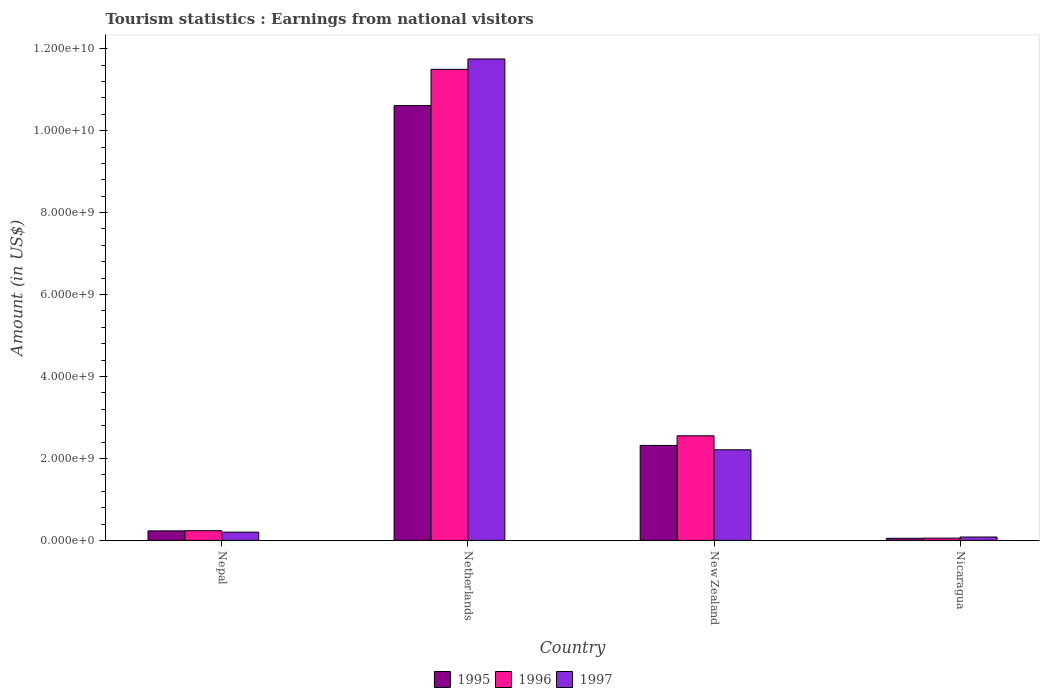How many different coloured bars are there?
Ensure brevity in your answer.  3. Are the number of bars per tick equal to the number of legend labels?
Your response must be concise. Yes. Are the number of bars on each tick of the X-axis equal?
Your response must be concise. Yes. How many bars are there on the 1st tick from the left?
Offer a very short reply. 3. What is the label of the 4th group of bars from the left?
Provide a short and direct response. Nicaragua. What is the earnings from national visitors in 1997 in Netherlands?
Give a very brief answer. 1.18e+1. Across all countries, what is the maximum earnings from national visitors in 1996?
Offer a terse response. 1.15e+1. Across all countries, what is the minimum earnings from national visitors in 1995?
Your response must be concise. 5.10e+07. In which country was the earnings from national visitors in 1995 maximum?
Ensure brevity in your answer.  Netherlands. In which country was the earnings from national visitors in 1996 minimum?
Ensure brevity in your answer.  Nicaragua. What is the total earnings from national visitors in 1996 in the graph?
Your response must be concise. 1.43e+1. What is the difference between the earnings from national visitors in 1996 in Nepal and that in Netherlands?
Provide a short and direct response. -1.13e+1. What is the difference between the earnings from national visitors in 1995 in Nepal and the earnings from national visitors in 1997 in Netherlands?
Your response must be concise. -1.15e+1. What is the average earnings from national visitors in 1996 per country?
Provide a succinct answer. 3.59e+09. What is the difference between the earnings from national visitors of/in 1995 and earnings from national visitors of/in 1997 in Netherlands?
Offer a terse response. -1.14e+09. What is the ratio of the earnings from national visitors in 1995 in Nepal to that in Netherlands?
Your answer should be compact. 0.02. Is the earnings from national visitors in 1996 in Nepal less than that in New Zealand?
Offer a very short reply. Yes. Is the difference between the earnings from national visitors in 1995 in Nepal and New Zealand greater than the difference between the earnings from national visitors in 1997 in Nepal and New Zealand?
Offer a terse response. No. What is the difference between the highest and the second highest earnings from national visitors in 1996?
Your answer should be very brief. 8.94e+09. What is the difference between the highest and the lowest earnings from national visitors in 1996?
Ensure brevity in your answer.  1.14e+1. In how many countries, is the earnings from national visitors in 1995 greater than the average earnings from national visitors in 1995 taken over all countries?
Your response must be concise. 1. Is the sum of the earnings from national visitors in 1997 in Netherlands and Nicaragua greater than the maximum earnings from national visitors in 1995 across all countries?
Your answer should be compact. Yes. What does the 1st bar from the left in New Zealand represents?
Offer a terse response. 1995. How many countries are there in the graph?
Offer a terse response. 4. What is the difference between two consecutive major ticks on the Y-axis?
Ensure brevity in your answer.  2.00e+09. Does the graph contain grids?
Make the answer very short. No. What is the title of the graph?
Provide a succinct answer. Tourism statistics : Earnings from national visitors. What is the Amount (in US$) in 1995 in Nepal?
Offer a very short reply. 2.32e+08. What is the Amount (in US$) in 1996 in Nepal?
Keep it short and to the point. 2.37e+08. What is the Amount (in US$) of 1997 in Nepal?
Your answer should be very brief. 2.01e+08. What is the Amount (in US$) of 1995 in Netherlands?
Offer a terse response. 1.06e+1. What is the Amount (in US$) of 1996 in Netherlands?
Provide a short and direct response. 1.15e+1. What is the Amount (in US$) in 1997 in Netherlands?
Keep it short and to the point. 1.18e+1. What is the Amount (in US$) of 1995 in New Zealand?
Provide a succinct answer. 2.32e+09. What is the Amount (in US$) in 1996 in New Zealand?
Offer a terse response. 2.55e+09. What is the Amount (in US$) in 1997 in New Zealand?
Provide a succinct answer. 2.21e+09. What is the Amount (in US$) in 1995 in Nicaragua?
Keep it short and to the point. 5.10e+07. What is the Amount (in US$) of 1996 in Nicaragua?
Make the answer very short. 5.50e+07. What is the Amount (in US$) of 1997 in Nicaragua?
Make the answer very short. 8.20e+07. Across all countries, what is the maximum Amount (in US$) in 1995?
Your answer should be compact. 1.06e+1. Across all countries, what is the maximum Amount (in US$) in 1996?
Your answer should be compact. 1.15e+1. Across all countries, what is the maximum Amount (in US$) of 1997?
Your answer should be very brief. 1.18e+1. Across all countries, what is the minimum Amount (in US$) of 1995?
Your response must be concise. 5.10e+07. Across all countries, what is the minimum Amount (in US$) in 1996?
Your answer should be very brief. 5.50e+07. Across all countries, what is the minimum Amount (in US$) in 1997?
Offer a very short reply. 8.20e+07. What is the total Amount (in US$) in 1995 in the graph?
Your answer should be compact. 1.32e+1. What is the total Amount (in US$) of 1996 in the graph?
Offer a very short reply. 1.43e+1. What is the total Amount (in US$) of 1997 in the graph?
Make the answer very short. 1.42e+1. What is the difference between the Amount (in US$) of 1995 in Nepal and that in Netherlands?
Give a very brief answer. -1.04e+1. What is the difference between the Amount (in US$) in 1996 in Nepal and that in Netherlands?
Your response must be concise. -1.13e+1. What is the difference between the Amount (in US$) in 1997 in Nepal and that in Netherlands?
Give a very brief answer. -1.15e+1. What is the difference between the Amount (in US$) in 1995 in Nepal and that in New Zealand?
Your answer should be very brief. -2.09e+09. What is the difference between the Amount (in US$) of 1996 in Nepal and that in New Zealand?
Your answer should be very brief. -2.32e+09. What is the difference between the Amount (in US$) of 1997 in Nepal and that in New Zealand?
Your answer should be very brief. -2.01e+09. What is the difference between the Amount (in US$) in 1995 in Nepal and that in Nicaragua?
Provide a succinct answer. 1.81e+08. What is the difference between the Amount (in US$) in 1996 in Nepal and that in Nicaragua?
Provide a succinct answer. 1.82e+08. What is the difference between the Amount (in US$) of 1997 in Nepal and that in Nicaragua?
Offer a terse response. 1.19e+08. What is the difference between the Amount (in US$) in 1995 in Netherlands and that in New Zealand?
Give a very brief answer. 8.29e+09. What is the difference between the Amount (in US$) of 1996 in Netherlands and that in New Zealand?
Offer a terse response. 8.94e+09. What is the difference between the Amount (in US$) in 1997 in Netherlands and that in New Zealand?
Your answer should be very brief. 9.54e+09. What is the difference between the Amount (in US$) in 1995 in Netherlands and that in Nicaragua?
Give a very brief answer. 1.06e+1. What is the difference between the Amount (in US$) in 1996 in Netherlands and that in Nicaragua?
Ensure brevity in your answer.  1.14e+1. What is the difference between the Amount (in US$) in 1997 in Netherlands and that in Nicaragua?
Ensure brevity in your answer.  1.17e+1. What is the difference between the Amount (in US$) of 1995 in New Zealand and that in Nicaragua?
Provide a succinct answer. 2.27e+09. What is the difference between the Amount (in US$) in 1996 in New Zealand and that in Nicaragua?
Ensure brevity in your answer.  2.50e+09. What is the difference between the Amount (in US$) in 1997 in New Zealand and that in Nicaragua?
Give a very brief answer. 2.13e+09. What is the difference between the Amount (in US$) in 1995 in Nepal and the Amount (in US$) in 1996 in Netherlands?
Keep it short and to the point. -1.13e+1. What is the difference between the Amount (in US$) in 1995 in Nepal and the Amount (in US$) in 1997 in Netherlands?
Make the answer very short. -1.15e+1. What is the difference between the Amount (in US$) in 1996 in Nepal and the Amount (in US$) in 1997 in Netherlands?
Ensure brevity in your answer.  -1.15e+1. What is the difference between the Amount (in US$) of 1995 in Nepal and the Amount (in US$) of 1996 in New Zealand?
Ensure brevity in your answer.  -2.32e+09. What is the difference between the Amount (in US$) of 1995 in Nepal and the Amount (in US$) of 1997 in New Zealand?
Offer a very short reply. -1.98e+09. What is the difference between the Amount (in US$) of 1996 in Nepal and the Amount (in US$) of 1997 in New Zealand?
Provide a succinct answer. -1.97e+09. What is the difference between the Amount (in US$) in 1995 in Nepal and the Amount (in US$) in 1996 in Nicaragua?
Provide a succinct answer. 1.77e+08. What is the difference between the Amount (in US$) of 1995 in Nepal and the Amount (in US$) of 1997 in Nicaragua?
Ensure brevity in your answer.  1.50e+08. What is the difference between the Amount (in US$) in 1996 in Nepal and the Amount (in US$) in 1997 in Nicaragua?
Offer a terse response. 1.55e+08. What is the difference between the Amount (in US$) of 1995 in Netherlands and the Amount (in US$) of 1996 in New Zealand?
Provide a succinct answer. 8.06e+09. What is the difference between the Amount (in US$) of 1995 in Netherlands and the Amount (in US$) of 1997 in New Zealand?
Your response must be concise. 8.40e+09. What is the difference between the Amount (in US$) of 1996 in Netherlands and the Amount (in US$) of 1997 in New Zealand?
Keep it short and to the point. 9.29e+09. What is the difference between the Amount (in US$) in 1995 in Netherlands and the Amount (in US$) in 1996 in Nicaragua?
Make the answer very short. 1.06e+1. What is the difference between the Amount (in US$) in 1995 in Netherlands and the Amount (in US$) in 1997 in Nicaragua?
Offer a terse response. 1.05e+1. What is the difference between the Amount (in US$) of 1996 in Netherlands and the Amount (in US$) of 1997 in Nicaragua?
Your response must be concise. 1.14e+1. What is the difference between the Amount (in US$) of 1995 in New Zealand and the Amount (in US$) of 1996 in Nicaragua?
Make the answer very short. 2.26e+09. What is the difference between the Amount (in US$) in 1995 in New Zealand and the Amount (in US$) in 1997 in Nicaragua?
Make the answer very short. 2.24e+09. What is the difference between the Amount (in US$) of 1996 in New Zealand and the Amount (in US$) of 1997 in Nicaragua?
Offer a terse response. 2.47e+09. What is the average Amount (in US$) of 1995 per country?
Provide a succinct answer. 3.30e+09. What is the average Amount (in US$) of 1996 per country?
Your answer should be very brief. 3.59e+09. What is the average Amount (in US$) in 1997 per country?
Offer a terse response. 3.56e+09. What is the difference between the Amount (in US$) in 1995 and Amount (in US$) in 1996 in Nepal?
Offer a terse response. -5.00e+06. What is the difference between the Amount (in US$) in 1995 and Amount (in US$) in 1997 in Nepal?
Give a very brief answer. 3.10e+07. What is the difference between the Amount (in US$) in 1996 and Amount (in US$) in 1997 in Nepal?
Your answer should be compact. 3.60e+07. What is the difference between the Amount (in US$) of 1995 and Amount (in US$) of 1996 in Netherlands?
Give a very brief answer. -8.86e+08. What is the difference between the Amount (in US$) in 1995 and Amount (in US$) in 1997 in Netherlands?
Provide a succinct answer. -1.14e+09. What is the difference between the Amount (in US$) of 1996 and Amount (in US$) of 1997 in Netherlands?
Offer a terse response. -2.53e+08. What is the difference between the Amount (in US$) in 1995 and Amount (in US$) in 1996 in New Zealand?
Make the answer very short. -2.35e+08. What is the difference between the Amount (in US$) of 1995 and Amount (in US$) of 1997 in New Zealand?
Your answer should be compact. 1.07e+08. What is the difference between the Amount (in US$) in 1996 and Amount (in US$) in 1997 in New Zealand?
Ensure brevity in your answer.  3.42e+08. What is the difference between the Amount (in US$) in 1995 and Amount (in US$) in 1997 in Nicaragua?
Provide a succinct answer. -3.10e+07. What is the difference between the Amount (in US$) of 1996 and Amount (in US$) of 1997 in Nicaragua?
Make the answer very short. -2.70e+07. What is the ratio of the Amount (in US$) in 1995 in Nepal to that in Netherlands?
Your answer should be compact. 0.02. What is the ratio of the Amount (in US$) of 1996 in Nepal to that in Netherlands?
Provide a short and direct response. 0.02. What is the ratio of the Amount (in US$) of 1997 in Nepal to that in Netherlands?
Give a very brief answer. 0.02. What is the ratio of the Amount (in US$) of 1995 in Nepal to that in New Zealand?
Ensure brevity in your answer.  0.1. What is the ratio of the Amount (in US$) of 1996 in Nepal to that in New Zealand?
Your response must be concise. 0.09. What is the ratio of the Amount (in US$) in 1997 in Nepal to that in New Zealand?
Your answer should be compact. 0.09. What is the ratio of the Amount (in US$) in 1995 in Nepal to that in Nicaragua?
Your answer should be very brief. 4.55. What is the ratio of the Amount (in US$) in 1996 in Nepal to that in Nicaragua?
Your answer should be compact. 4.31. What is the ratio of the Amount (in US$) in 1997 in Nepal to that in Nicaragua?
Your answer should be compact. 2.45. What is the ratio of the Amount (in US$) of 1995 in Netherlands to that in New Zealand?
Offer a very short reply. 4.58. What is the ratio of the Amount (in US$) in 1996 in Netherlands to that in New Zealand?
Your answer should be compact. 4.5. What is the ratio of the Amount (in US$) of 1997 in Netherlands to that in New Zealand?
Keep it short and to the point. 5.31. What is the ratio of the Amount (in US$) in 1995 in Netherlands to that in Nicaragua?
Your response must be concise. 208.06. What is the ratio of the Amount (in US$) in 1996 in Netherlands to that in Nicaragua?
Ensure brevity in your answer.  209.04. What is the ratio of the Amount (in US$) in 1997 in Netherlands to that in Nicaragua?
Make the answer very short. 143.29. What is the ratio of the Amount (in US$) of 1995 in New Zealand to that in Nicaragua?
Your answer should be very brief. 45.45. What is the ratio of the Amount (in US$) in 1996 in New Zealand to that in Nicaragua?
Ensure brevity in your answer.  46.42. What is the ratio of the Amount (in US$) of 1997 in New Zealand to that in Nicaragua?
Make the answer very short. 26.96. What is the difference between the highest and the second highest Amount (in US$) in 1995?
Offer a terse response. 8.29e+09. What is the difference between the highest and the second highest Amount (in US$) in 1996?
Offer a very short reply. 8.94e+09. What is the difference between the highest and the second highest Amount (in US$) in 1997?
Ensure brevity in your answer.  9.54e+09. What is the difference between the highest and the lowest Amount (in US$) in 1995?
Your response must be concise. 1.06e+1. What is the difference between the highest and the lowest Amount (in US$) of 1996?
Your answer should be very brief. 1.14e+1. What is the difference between the highest and the lowest Amount (in US$) of 1997?
Offer a terse response. 1.17e+1. 